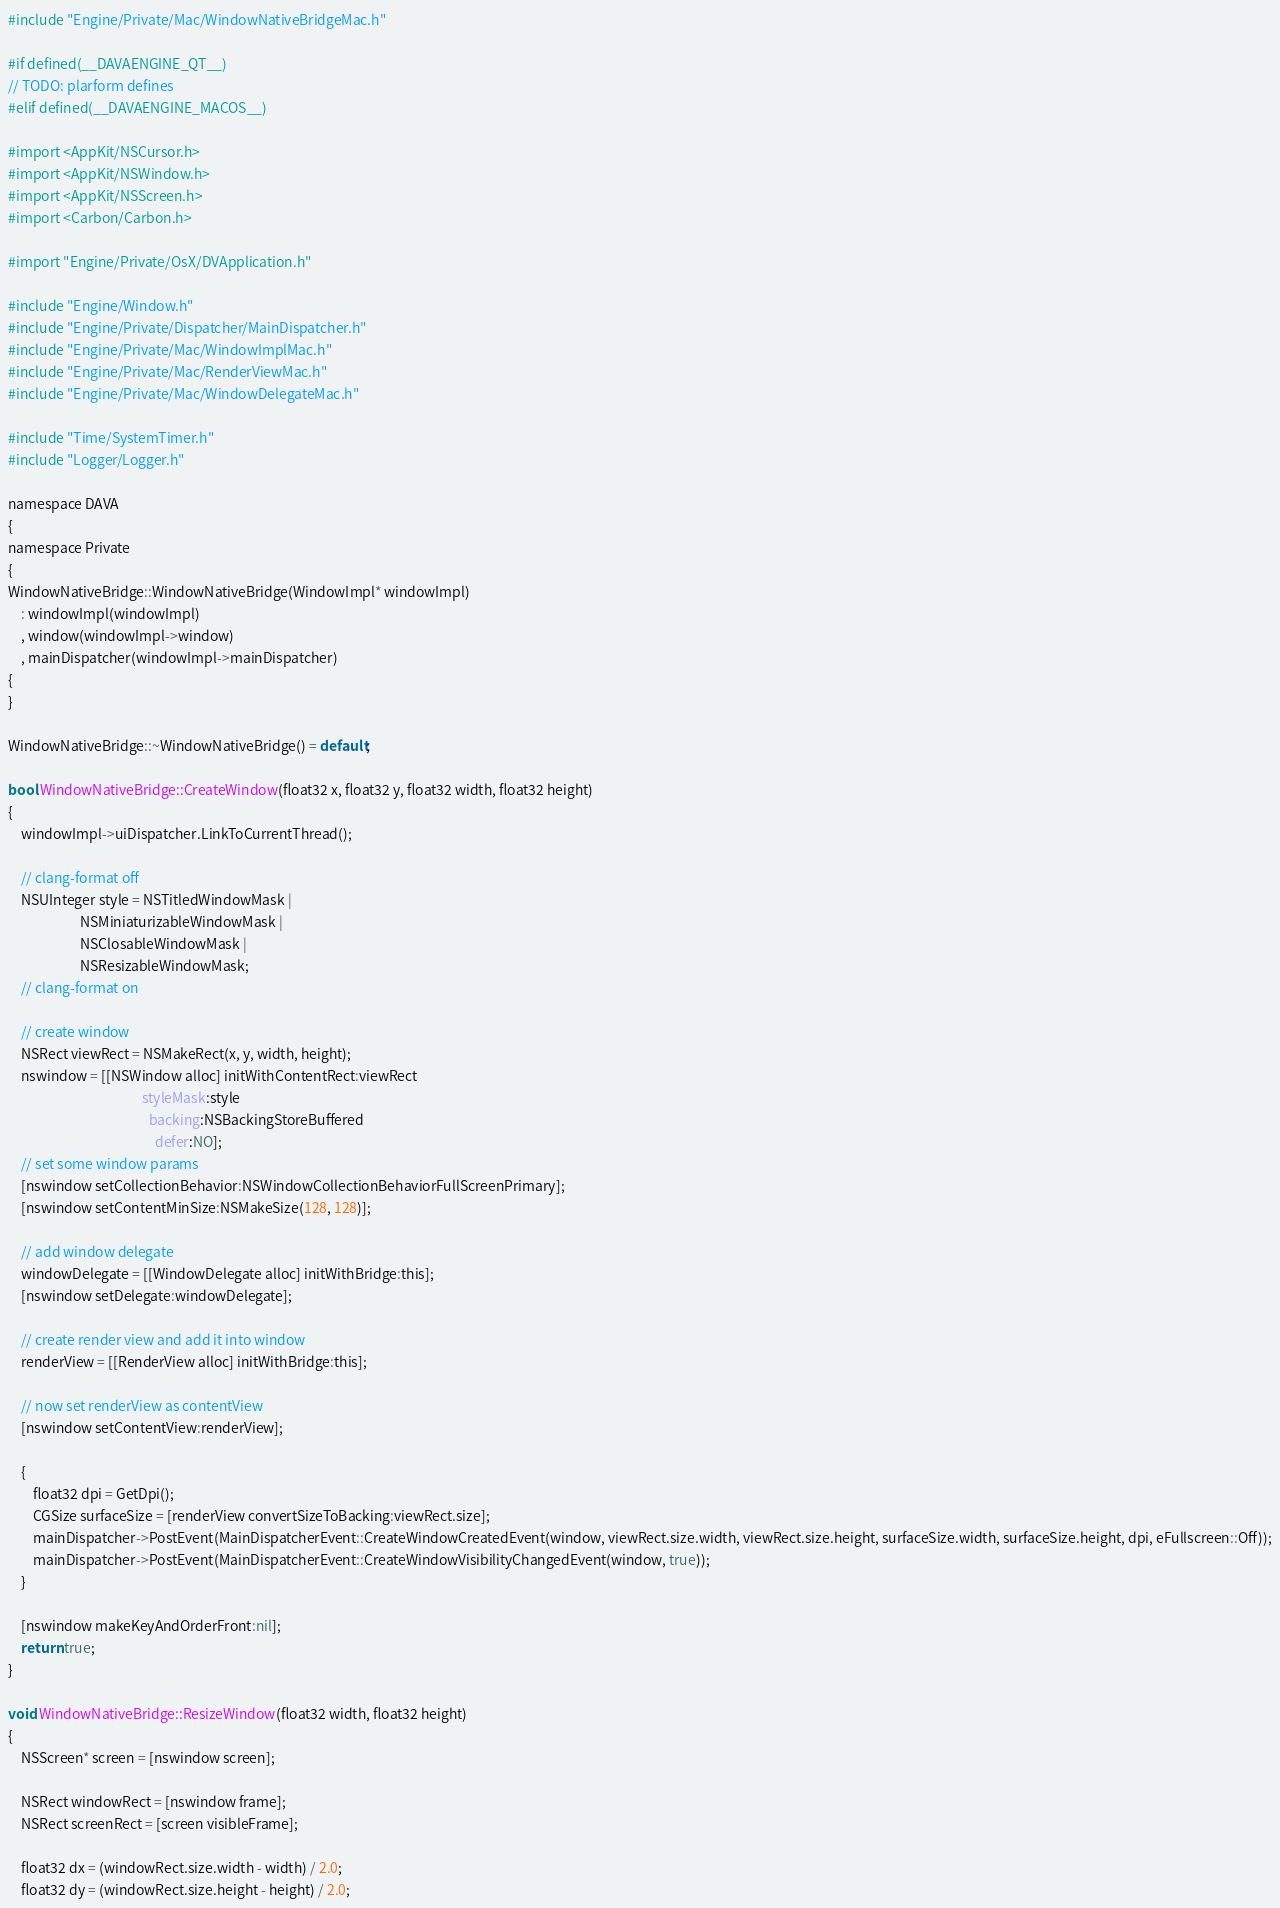Convert code to text. <code><loc_0><loc_0><loc_500><loc_500><_ObjectiveC_>#include "Engine/Private/Mac/WindowNativeBridgeMac.h"

#if defined(__DAVAENGINE_QT__)
// TODO: plarform defines
#elif defined(__DAVAENGINE_MACOS__)

#import <AppKit/NSCursor.h>
#import <AppKit/NSWindow.h>
#import <AppKit/NSScreen.h>
#import <Carbon/Carbon.h>

#import "Engine/Private/OsX/DVApplication.h"

#include "Engine/Window.h"
#include "Engine/Private/Dispatcher/MainDispatcher.h"
#include "Engine/Private/Mac/WindowImplMac.h"
#include "Engine/Private/Mac/RenderViewMac.h"
#include "Engine/Private/Mac/WindowDelegateMac.h"

#include "Time/SystemTimer.h"
#include "Logger/Logger.h"

namespace DAVA
{
namespace Private
{
WindowNativeBridge::WindowNativeBridge(WindowImpl* windowImpl)
    : windowImpl(windowImpl)
    , window(windowImpl->window)
    , mainDispatcher(windowImpl->mainDispatcher)
{
}

WindowNativeBridge::~WindowNativeBridge() = default;

bool WindowNativeBridge::CreateWindow(float32 x, float32 y, float32 width, float32 height)
{
    windowImpl->uiDispatcher.LinkToCurrentThread();

    // clang-format off
    NSUInteger style = NSTitledWindowMask |
                       NSMiniaturizableWindowMask |
                       NSClosableWindowMask |
                       NSResizableWindowMask;
    // clang-format on

    // create window
    NSRect viewRect = NSMakeRect(x, y, width, height);
    nswindow = [[NSWindow alloc] initWithContentRect:viewRect
                                           styleMask:style
                                             backing:NSBackingStoreBuffered
                                               defer:NO];
    // set some window params
    [nswindow setCollectionBehavior:NSWindowCollectionBehaviorFullScreenPrimary];
    [nswindow setContentMinSize:NSMakeSize(128, 128)];

    // add window delegate
    windowDelegate = [[WindowDelegate alloc] initWithBridge:this];
    [nswindow setDelegate:windowDelegate];

    // create render view and add it into window
    renderView = [[RenderView alloc] initWithBridge:this];

    // now set renderView as contentView
    [nswindow setContentView:renderView];

    {
        float32 dpi = GetDpi();
        CGSize surfaceSize = [renderView convertSizeToBacking:viewRect.size];
        mainDispatcher->PostEvent(MainDispatcherEvent::CreateWindowCreatedEvent(window, viewRect.size.width, viewRect.size.height, surfaceSize.width, surfaceSize.height, dpi, eFullscreen::Off));
        mainDispatcher->PostEvent(MainDispatcherEvent::CreateWindowVisibilityChangedEvent(window, true));
    }

    [nswindow makeKeyAndOrderFront:nil];
    return true;
}

void WindowNativeBridge::ResizeWindow(float32 width, float32 height)
{
    NSScreen* screen = [nswindow screen];

    NSRect windowRect = [nswindow frame];
    NSRect screenRect = [screen visibleFrame];

    float32 dx = (windowRect.size.width - width) / 2.0;
    float32 dy = (windowRect.size.height - height) / 2.0;
</code> 